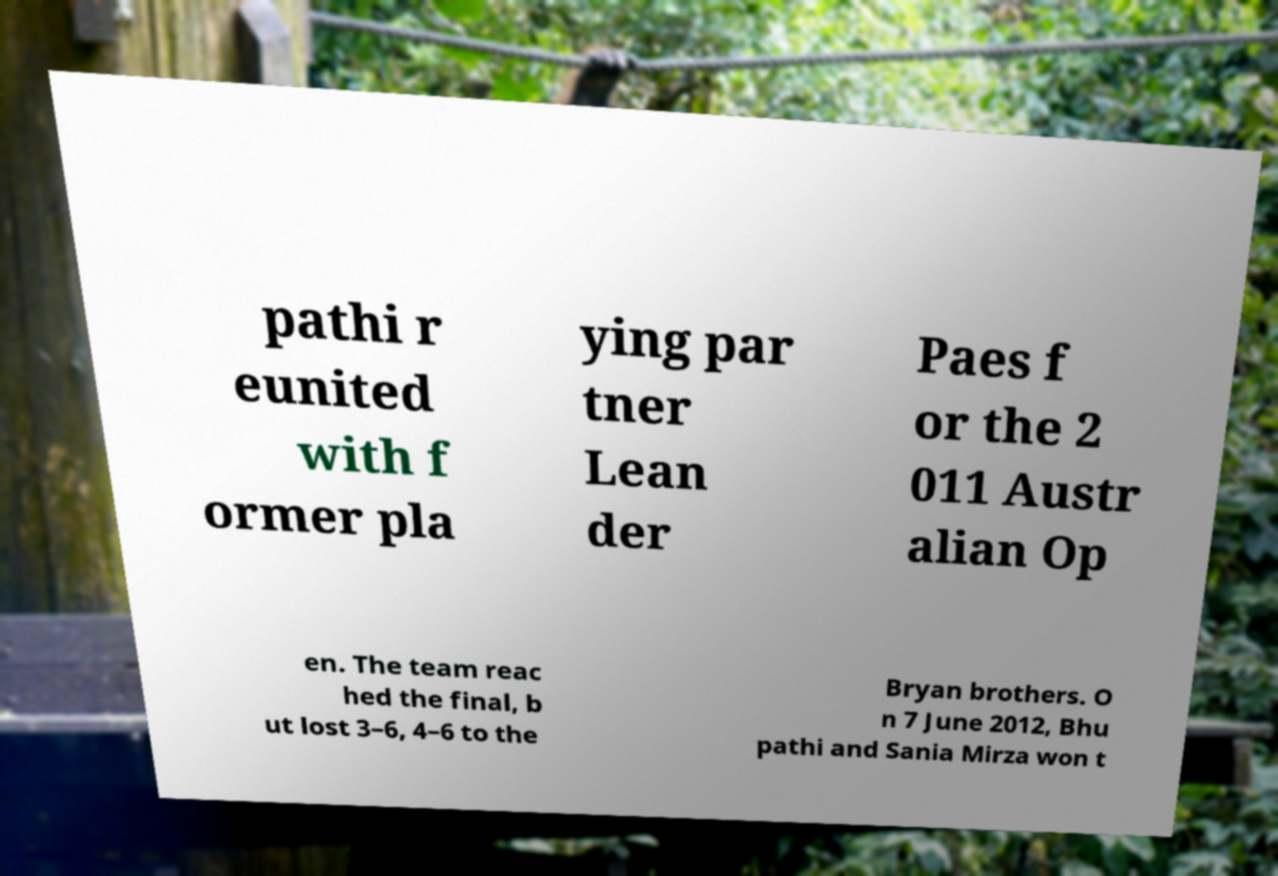For documentation purposes, I need the text within this image transcribed. Could you provide that? pathi r eunited with f ormer pla ying par tner Lean der Paes f or the 2 011 Austr alian Op en. The team reac hed the final, b ut lost 3–6, 4–6 to the Bryan brothers. O n 7 June 2012, Bhu pathi and Sania Mirza won t 